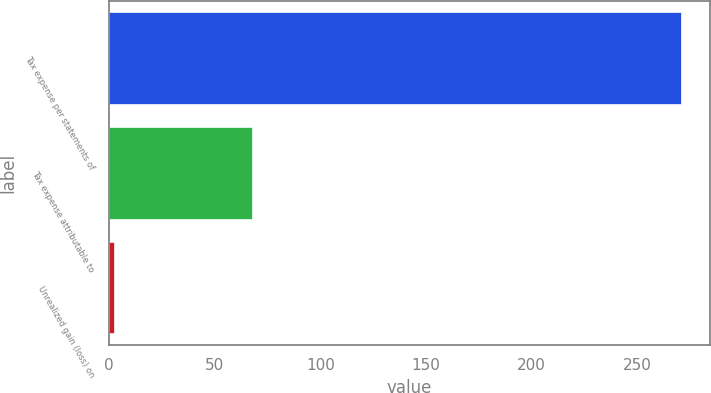<chart> <loc_0><loc_0><loc_500><loc_500><bar_chart><fcel>Tax expense per statements of<fcel>Tax expense attributable to<fcel>Unrealized gain (loss) on<nl><fcel>270.9<fcel>67.4<fcel>2.1<nl></chart> 